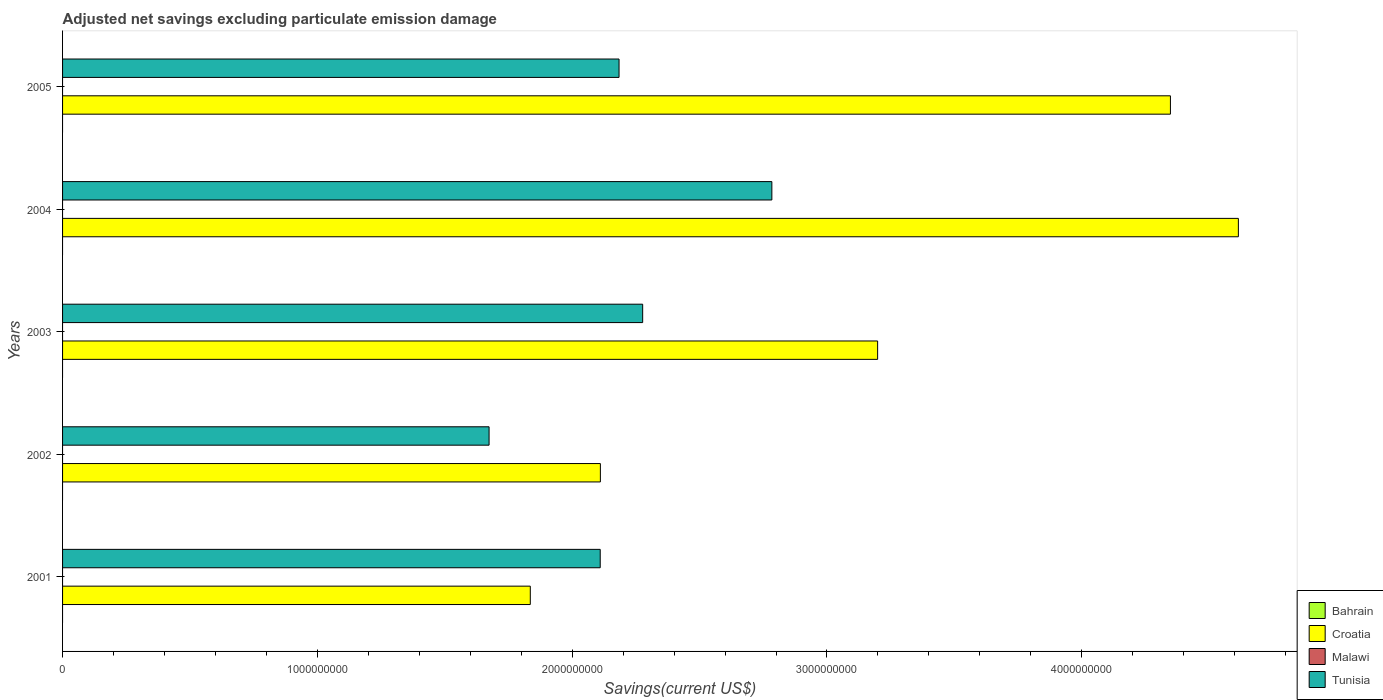Are the number of bars per tick equal to the number of legend labels?
Offer a terse response. No. Are the number of bars on each tick of the Y-axis equal?
Provide a succinct answer. Yes. How many bars are there on the 3rd tick from the top?
Offer a very short reply. 2. What is the adjusted net savings in Croatia in 2001?
Offer a very short reply. 1.84e+09. Across all years, what is the maximum adjusted net savings in Croatia?
Ensure brevity in your answer.  4.61e+09. Across all years, what is the minimum adjusted net savings in Bahrain?
Make the answer very short. 0. What is the total adjusted net savings in Croatia in the graph?
Provide a succinct answer. 1.61e+1. What is the difference between the adjusted net savings in Tunisia in 2001 and that in 2003?
Provide a succinct answer. -1.67e+08. What is the difference between the adjusted net savings in Croatia in 2004 and the adjusted net savings in Tunisia in 2005?
Offer a very short reply. 2.43e+09. In the year 2004, what is the difference between the adjusted net savings in Tunisia and adjusted net savings in Croatia?
Provide a succinct answer. -1.83e+09. What is the ratio of the adjusted net savings in Tunisia in 2004 to that in 2005?
Give a very brief answer. 1.27. Is the adjusted net savings in Tunisia in 2003 less than that in 2005?
Your answer should be very brief. No. Is the difference between the adjusted net savings in Tunisia in 2001 and 2003 greater than the difference between the adjusted net savings in Croatia in 2001 and 2003?
Provide a succinct answer. Yes. What is the difference between the highest and the second highest adjusted net savings in Tunisia?
Offer a very short reply. 5.07e+08. In how many years, is the adjusted net savings in Tunisia greater than the average adjusted net savings in Tunisia taken over all years?
Offer a very short reply. 2. Is it the case that in every year, the sum of the adjusted net savings in Tunisia and adjusted net savings in Malawi is greater than the sum of adjusted net savings in Bahrain and adjusted net savings in Croatia?
Your response must be concise. No. Is it the case that in every year, the sum of the adjusted net savings in Tunisia and adjusted net savings in Malawi is greater than the adjusted net savings in Bahrain?
Your answer should be very brief. Yes. How many years are there in the graph?
Give a very brief answer. 5. What is the difference between two consecutive major ticks on the X-axis?
Make the answer very short. 1.00e+09. Are the values on the major ticks of X-axis written in scientific E-notation?
Make the answer very short. No. Does the graph contain any zero values?
Provide a short and direct response. Yes. Does the graph contain grids?
Your answer should be compact. No. Where does the legend appear in the graph?
Provide a short and direct response. Bottom right. How many legend labels are there?
Your response must be concise. 4. What is the title of the graph?
Your answer should be compact. Adjusted net savings excluding particulate emission damage. What is the label or title of the X-axis?
Give a very brief answer. Savings(current US$). What is the label or title of the Y-axis?
Make the answer very short. Years. What is the Savings(current US$) in Bahrain in 2001?
Your response must be concise. 0. What is the Savings(current US$) in Croatia in 2001?
Offer a very short reply. 1.84e+09. What is the Savings(current US$) of Tunisia in 2001?
Give a very brief answer. 2.11e+09. What is the Savings(current US$) in Croatia in 2002?
Offer a very short reply. 2.11e+09. What is the Savings(current US$) in Tunisia in 2002?
Ensure brevity in your answer.  1.67e+09. What is the Savings(current US$) of Bahrain in 2003?
Provide a succinct answer. 0. What is the Savings(current US$) in Croatia in 2003?
Your answer should be very brief. 3.20e+09. What is the Savings(current US$) of Malawi in 2003?
Make the answer very short. 0. What is the Savings(current US$) of Tunisia in 2003?
Your response must be concise. 2.28e+09. What is the Savings(current US$) of Bahrain in 2004?
Offer a terse response. 0. What is the Savings(current US$) of Croatia in 2004?
Your response must be concise. 4.61e+09. What is the Savings(current US$) in Tunisia in 2004?
Provide a succinct answer. 2.78e+09. What is the Savings(current US$) of Bahrain in 2005?
Your answer should be very brief. 0. What is the Savings(current US$) of Croatia in 2005?
Provide a short and direct response. 4.35e+09. What is the Savings(current US$) in Malawi in 2005?
Offer a very short reply. 0. What is the Savings(current US$) of Tunisia in 2005?
Your answer should be very brief. 2.18e+09. Across all years, what is the maximum Savings(current US$) in Croatia?
Keep it short and to the point. 4.61e+09. Across all years, what is the maximum Savings(current US$) in Tunisia?
Keep it short and to the point. 2.78e+09. Across all years, what is the minimum Savings(current US$) of Croatia?
Your answer should be compact. 1.84e+09. Across all years, what is the minimum Savings(current US$) in Tunisia?
Provide a succinct answer. 1.67e+09. What is the total Savings(current US$) of Croatia in the graph?
Keep it short and to the point. 1.61e+1. What is the total Savings(current US$) in Malawi in the graph?
Your response must be concise. 0. What is the total Savings(current US$) in Tunisia in the graph?
Your answer should be compact. 1.10e+1. What is the difference between the Savings(current US$) of Croatia in 2001 and that in 2002?
Your answer should be very brief. -2.75e+08. What is the difference between the Savings(current US$) of Tunisia in 2001 and that in 2002?
Provide a short and direct response. 4.36e+08. What is the difference between the Savings(current US$) in Croatia in 2001 and that in 2003?
Make the answer very short. -1.36e+09. What is the difference between the Savings(current US$) of Tunisia in 2001 and that in 2003?
Offer a very short reply. -1.67e+08. What is the difference between the Savings(current US$) of Croatia in 2001 and that in 2004?
Keep it short and to the point. -2.78e+09. What is the difference between the Savings(current US$) in Tunisia in 2001 and that in 2004?
Your answer should be compact. -6.74e+08. What is the difference between the Savings(current US$) in Croatia in 2001 and that in 2005?
Your answer should be very brief. -2.51e+09. What is the difference between the Savings(current US$) of Tunisia in 2001 and that in 2005?
Keep it short and to the point. -7.39e+07. What is the difference between the Savings(current US$) of Croatia in 2002 and that in 2003?
Provide a succinct answer. -1.09e+09. What is the difference between the Savings(current US$) in Tunisia in 2002 and that in 2003?
Provide a succinct answer. -6.03e+08. What is the difference between the Savings(current US$) in Croatia in 2002 and that in 2004?
Your response must be concise. -2.50e+09. What is the difference between the Savings(current US$) in Tunisia in 2002 and that in 2004?
Ensure brevity in your answer.  -1.11e+09. What is the difference between the Savings(current US$) in Croatia in 2002 and that in 2005?
Ensure brevity in your answer.  -2.24e+09. What is the difference between the Savings(current US$) of Tunisia in 2002 and that in 2005?
Your answer should be very brief. -5.10e+08. What is the difference between the Savings(current US$) of Croatia in 2003 and that in 2004?
Give a very brief answer. -1.42e+09. What is the difference between the Savings(current US$) in Tunisia in 2003 and that in 2004?
Give a very brief answer. -5.07e+08. What is the difference between the Savings(current US$) of Croatia in 2003 and that in 2005?
Your answer should be very brief. -1.15e+09. What is the difference between the Savings(current US$) in Tunisia in 2003 and that in 2005?
Keep it short and to the point. 9.27e+07. What is the difference between the Savings(current US$) of Croatia in 2004 and that in 2005?
Keep it short and to the point. 2.67e+08. What is the difference between the Savings(current US$) in Tunisia in 2004 and that in 2005?
Keep it short and to the point. 6.00e+08. What is the difference between the Savings(current US$) of Croatia in 2001 and the Savings(current US$) of Tunisia in 2002?
Your answer should be very brief. 1.62e+08. What is the difference between the Savings(current US$) in Croatia in 2001 and the Savings(current US$) in Tunisia in 2003?
Keep it short and to the point. -4.41e+08. What is the difference between the Savings(current US$) in Croatia in 2001 and the Savings(current US$) in Tunisia in 2004?
Give a very brief answer. -9.48e+08. What is the difference between the Savings(current US$) of Croatia in 2001 and the Savings(current US$) of Tunisia in 2005?
Offer a terse response. -3.48e+08. What is the difference between the Savings(current US$) in Croatia in 2002 and the Savings(current US$) in Tunisia in 2003?
Offer a very short reply. -1.66e+08. What is the difference between the Savings(current US$) of Croatia in 2002 and the Savings(current US$) of Tunisia in 2004?
Make the answer very short. -6.73e+08. What is the difference between the Savings(current US$) in Croatia in 2002 and the Savings(current US$) in Tunisia in 2005?
Make the answer very short. -7.33e+07. What is the difference between the Savings(current US$) of Croatia in 2003 and the Savings(current US$) of Tunisia in 2004?
Your answer should be compact. 4.15e+08. What is the difference between the Savings(current US$) of Croatia in 2003 and the Savings(current US$) of Tunisia in 2005?
Your response must be concise. 1.01e+09. What is the difference between the Savings(current US$) of Croatia in 2004 and the Savings(current US$) of Tunisia in 2005?
Ensure brevity in your answer.  2.43e+09. What is the average Savings(current US$) in Bahrain per year?
Provide a succinct answer. 0. What is the average Savings(current US$) in Croatia per year?
Ensure brevity in your answer.  3.22e+09. What is the average Savings(current US$) in Malawi per year?
Your answer should be compact. 0. What is the average Savings(current US$) of Tunisia per year?
Provide a succinct answer. 2.21e+09. In the year 2001, what is the difference between the Savings(current US$) of Croatia and Savings(current US$) of Tunisia?
Keep it short and to the point. -2.74e+08. In the year 2002, what is the difference between the Savings(current US$) in Croatia and Savings(current US$) in Tunisia?
Keep it short and to the point. 4.37e+08. In the year 2003, what is the difference between the Savings(current US$) of Croatia and Savings(current US$) of Tunisia?
Give a very brief answer. 9.22e+08. In the year 2004, what is the difference between the Savings(current US$) of Croatia and Savings(current US$) of Tunisia?
Provide a succinct answer. 1.83e+09. In the year 2005, what is the difference between the Savings(current US$) of Croatia and Savings(current US$) of Tunisia?
Your answer should be very brief. 2.16e+09. What is the ratio of the Savings(current US$) in Croatia in 2001 to that in 2002?
Your answer should be compact. 0.87. What is the ratio of the Savings(current US$) in Tunisia in 2001 to that in 2002?
Give a very brief answer. 1.26. What is the ratio of the Savings(current US$) in Croatia in 2001 to that in 2003?
Give a very brief answer. 0.57. What is the ratio of the Savings(current US$) in Tunisia in 2001 to that in 2003?
Make the answer very short. 0.93. What is the ratio of the Savings(current US$) of Croatia in 2001 to that in 2004?
Your response must be concise. 0.4. What is the ratio of the Savings(current US$) of Tunisia in 2001 to that in 2004?
Offer a very short reply. 0.76. What is the ratio of the Savings(current US$) in Croatia in 2001 to that in 2005?
Provide a succinct answer. 0.42. What is the ratio of the Savings(current US$) in Tunisia in 2001 to that in 2005?
Provide a short and direct response. 0.97. What is the ratio of the Savings(current US$) of Croatia in 2002 to that in 2003?
Make the answer very short. 0.66. What is the ratio of the Savings(current US$) in Tunisia in 2002 to that in 2003?
Offer a terse response. 0.74. What is the ratio of the Savings(current US$) of Croatia in 2002 to that in 2004?
Your response must be concise. 0.46. What is the ratio of the Savings(current US$) of Tunisia in 2002 to that in 2004?
Provide a succinct answer. 0.6. What is the ratio of the Savings(current US$) in Croatia in 2002 to that in 2005?
Provide a succinct answer. 0.49. What is the ratio of the Savings(current US$) of Tunisia in 2002 to that in 2005?
Offer a terse response. 0.77. What is the ratio of the Savings(current US$) in Croatia in 2003 to that in 2004?
Give a very brief answer. 0.69. What is the ratio of the Savings(current US$) in Tunisia in 2003 to that in 2004?
Your answer should be very brief. 0.82. What is the ratio of the Savings(current US$) of Croatia in 2003 to that in 2005?
Keep it short and to the point. 0.74. What is the ratio of the Savings(current US$) of Tunisia in 2003 to that in 2005?
Provide a short and direct response. 1.04. What is the ratio of the Savings(current US$) of Croatia in 2004 to that in 2005?
Offer a terse response. 1.06. What is the ratio of the Savings(current US$) of Tunisia in 2004 to that in 2005?
Ensure brevity in your answer.  1.27. What is the difference between the highest and the second highest Savings(current US$) of Croatia?
Keep it short and to the point. 2.67e+08. What is the difference between the highest and the second highest Savings(current US$) of Tunisia?
Offer a terse response. 5.07e+08. What is the difference between the highest and the lowest Savings(current US$) in Croatia?
Give a very brief answer. 2.78e+09. What is the difference between the highest and the lowest Savings(current US$) in Tunisia?
Your response must be concise. 1.11e+09. 